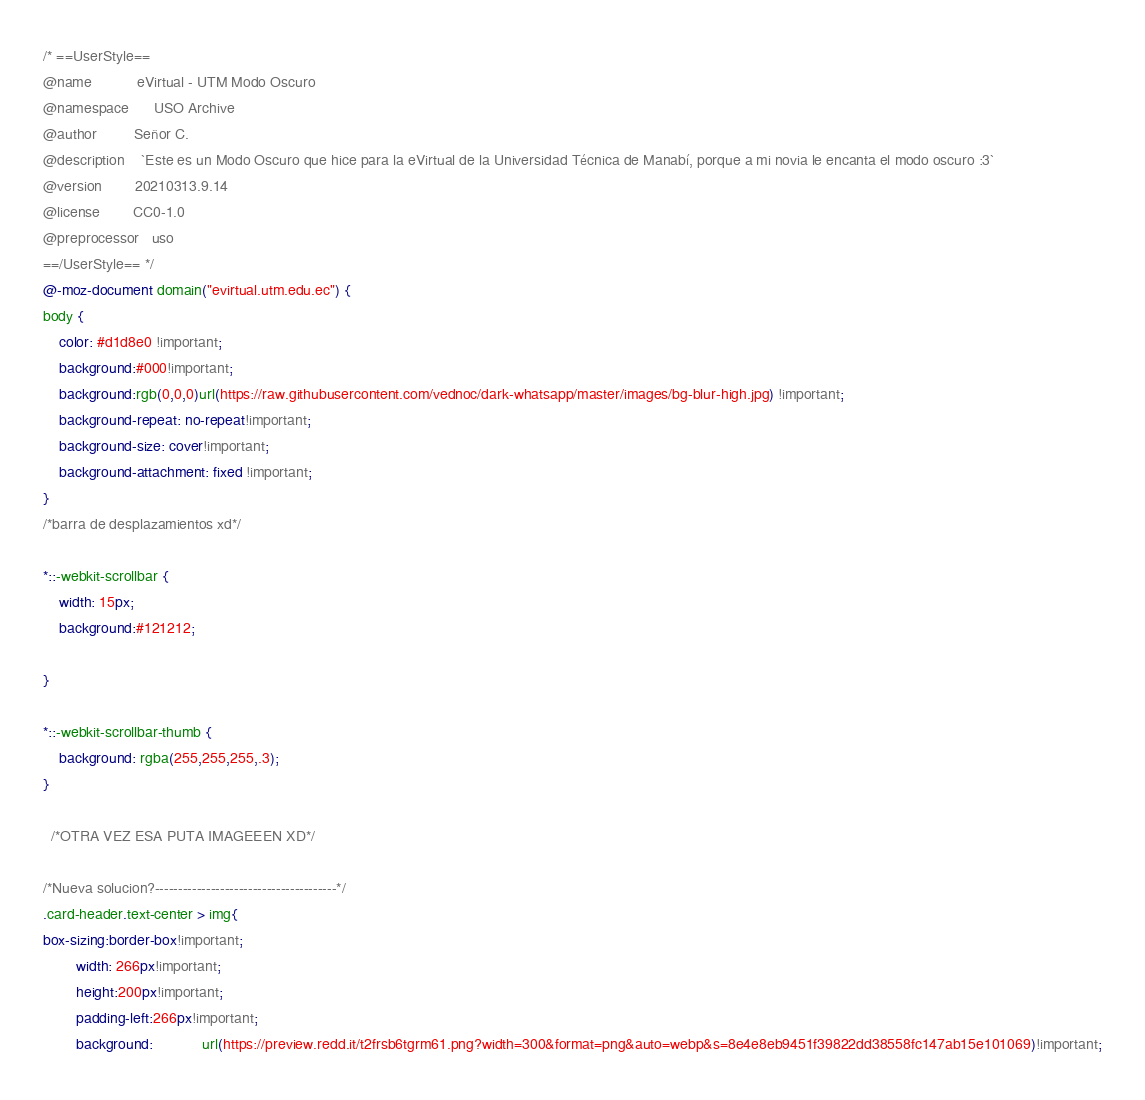<code> <loc_0><loc_0><loc_500><loc_500><_CSS_>/* ==UserStyle==
@name           eVirtual - UTM Modo Oscuro
@namespace      USO Archive
@author         Señor C.
@description    `Este es un Modo Oscuro que hice para la eVirtual de la Universidad Técnica de Manabí, porque a mi novia le encanta el modo oscuro :3`
@version        20210313.9.14
@license        CC0-1.0
@preprocessor   uso
==/UserStyle== */
@-moz-document domain("evirtual.utm.edu.ec") {
body {
    color: #d1d8e0 !important;
    background:#000!important;
    background:rgb(0,0,0)url(https://raw.githubusercontent.com/vednoc/dark-whatsapp/master/images/bg-blur-high.jpg) !important;
    background-repeat: no-repeat!important;
    background-size: cover!important;
    background-attachment: fixed !important;
}
/*barra de desplazamientos xd*/

*::-webkit-scrollbar {
	width: 15px;
	background:#121212;

}

*::-webkit-scrollbar-thumb {
	background: rgba(255,255,255,.3);
}
  
  /*OTRA VEZ ESA PUTA IMAGEEEN XD*/

/*Nueva solucion?---------------------------------------*/
.card-header.text-center > img{
box-sizing:border-box!important;
        width: 266px!important;
        height:200px!important;
        padding-left:266px!important; 
        background: 		 	url(https://preview.redd.it/t2frsb6tgrm61.png?width=300&format=png&auto=webp&s=8e4e8eb9451f39822dd38558fc147ab15e101069)!important;</code> 